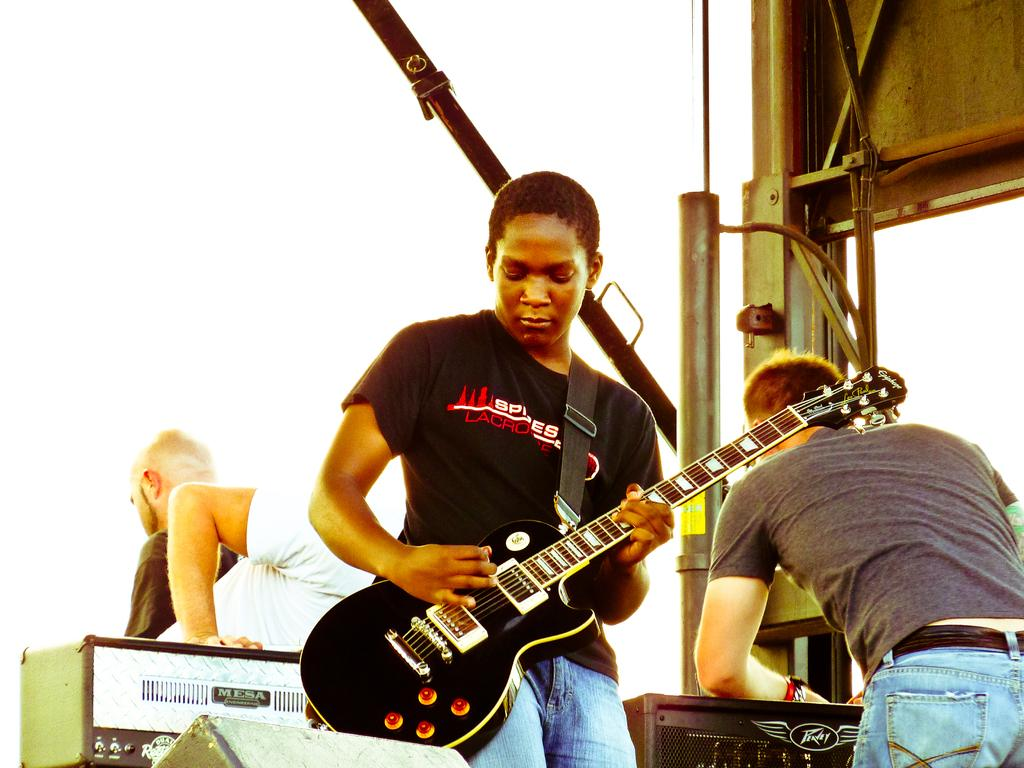How many people are present in the image? There are four people in the image. What activity is one of the people engaged in? One person is playing a guitar. What is the name of the person playing the guitar in the image? The provided facts do not include any names, so we cannot determine the name of the person playing the guitar in the image. 